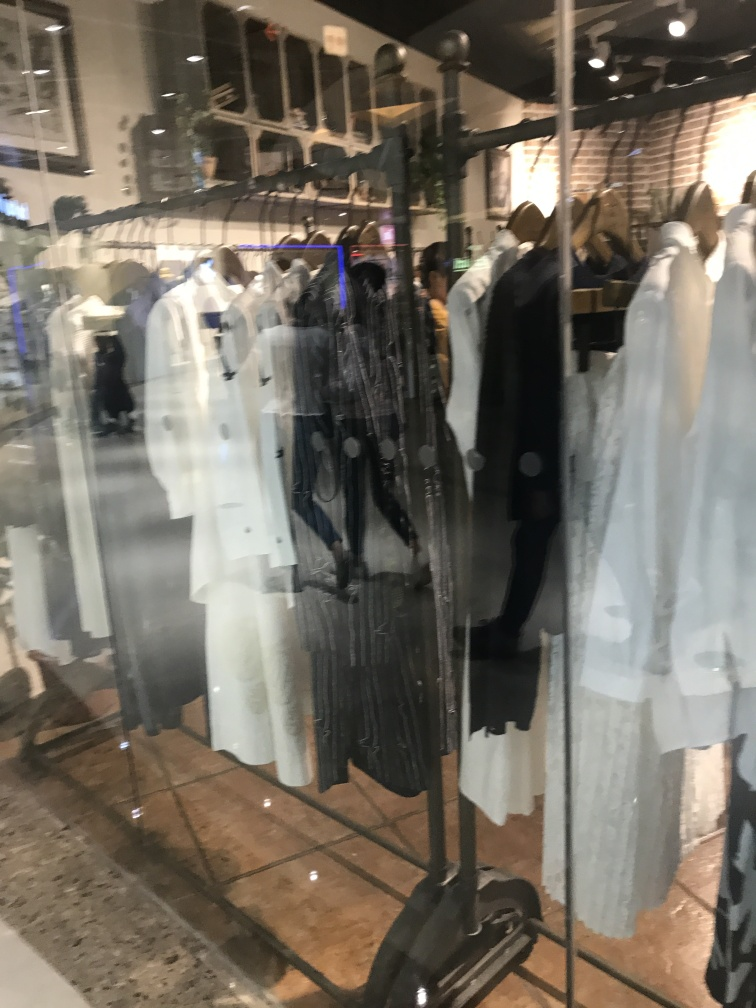What style of clothing is predominantly displayed in this image? The image showcases a variety of clothing items, with a focus on contemporary casual and semi-formal wear. This can be inferred from the styles of the jackets, trousers, and blouses on display. The clothing suggests a modern fashion retail environment. 